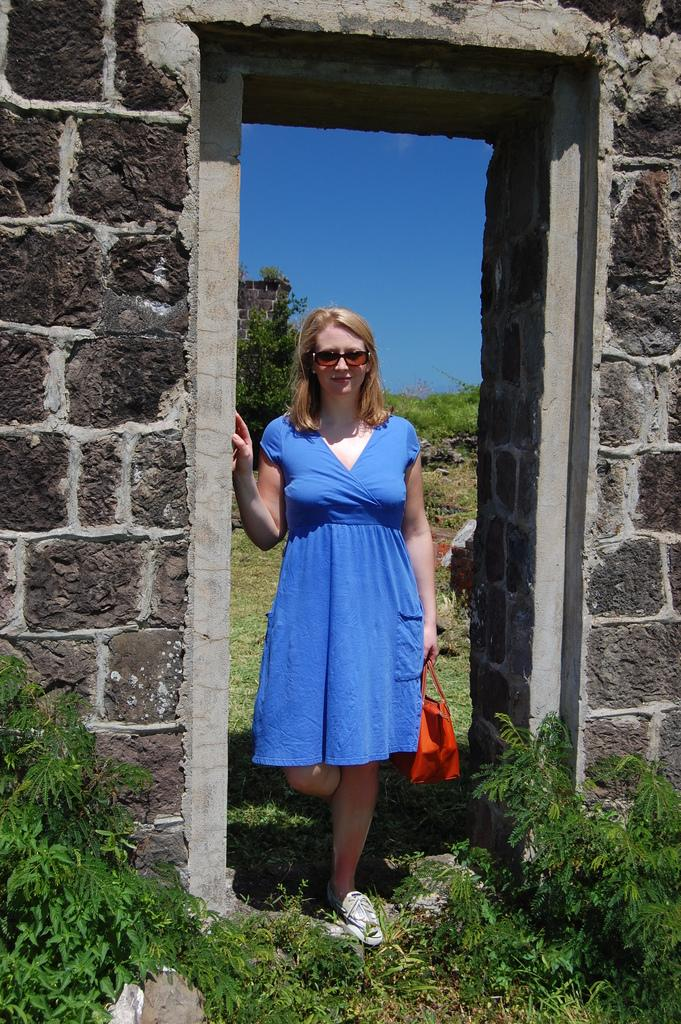Who is present in the image? There is a woman in the image. What is the woman wearing? The woman is wearing a blue dress. What accessory is the woman holding? The woman is holding a red handbag. What color is the ground in the image? The ground in the image is green. What can be seen on either side of the woman? There are walls on either side of the woman. What type of ticket does the woman have in her hand? The woman is not holding a ticket in her hand; she is holding a red handbag. Can you provide an example of a similar image with a different color scheme? The provided facts only describe the colors in this specific image, so it is not possible to provide an example of a similar image with a different color scheme. 